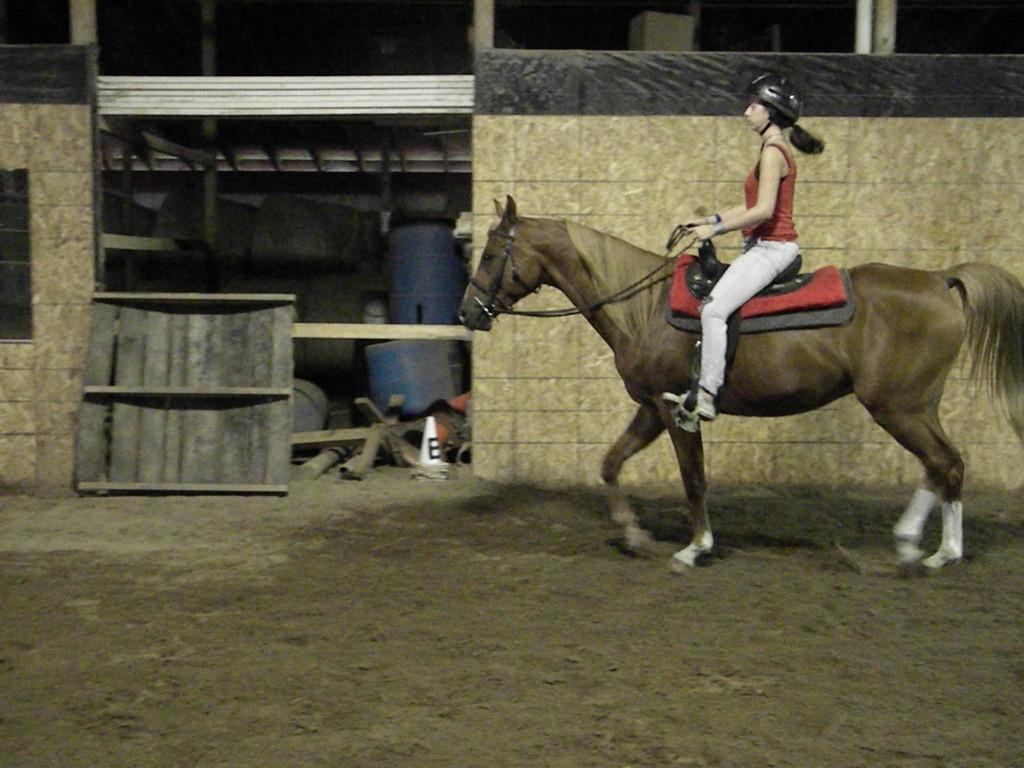Please provide a concise description of this image. In this image on the right side there is one woman who is sitting on a horse and riding, and in the background there is a building, wooden board, drums, wooden sticks, poles and some other objects. At the bottom there is a walkway. 